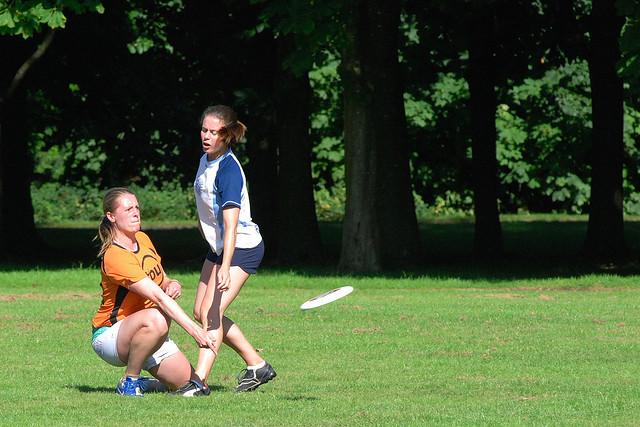Are they playing volleyball?
Short answer required. No. What is the green stuff on the ground called?
Answer briefly. Grass. How many people are there?
Answer briefly. 2. 